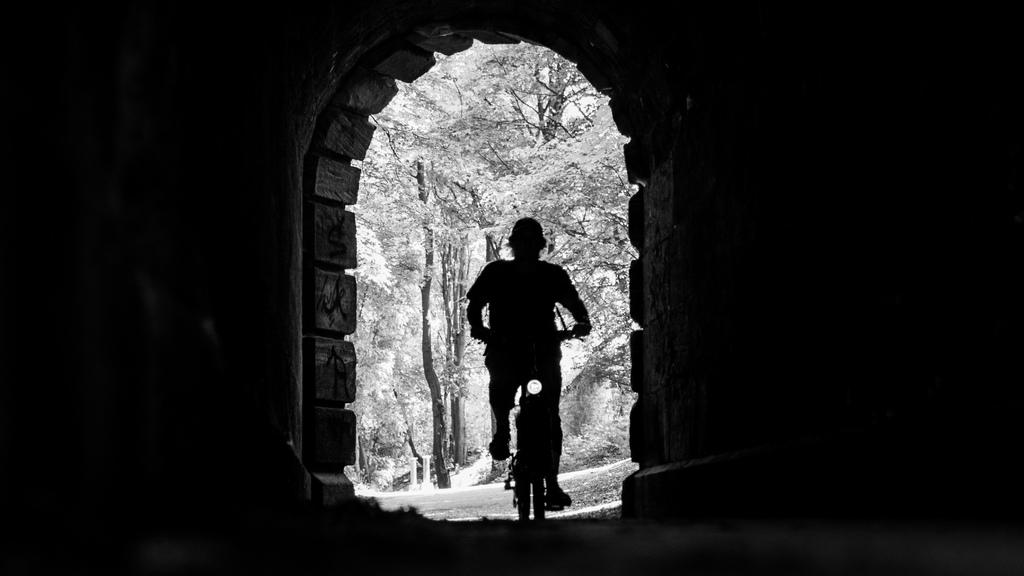What is the main subject of the image? There is a person riding a bicycle in the image. What can be seen in the background of the image? There are trees and an arch in the center of the background. Where is the toad hiding in the image? There is no toad present in the image. 